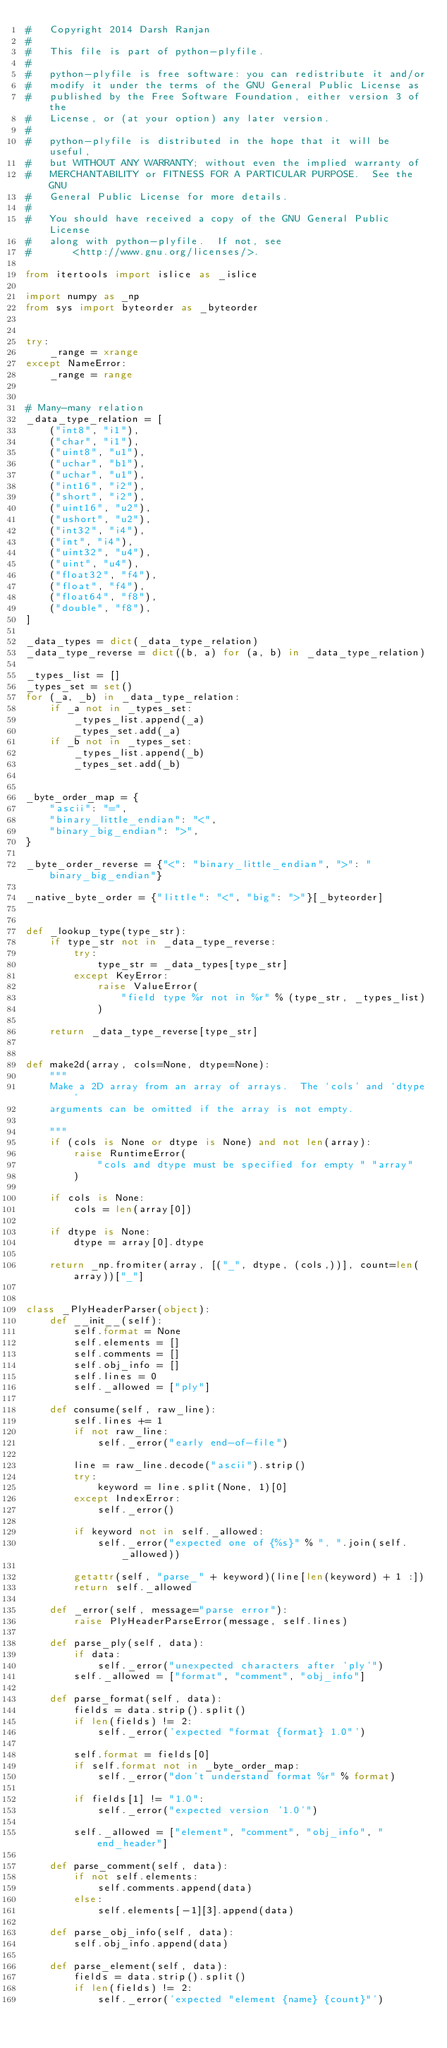<code> <loc_0><loc_0><loc_500><loc_500><_Python_>#   Copyright 2014 Darsh Ranjan
#
#   This file is part of python-plyfile.
#
#   python-plyfile is free software: you can redistribute it and/or
#   modify it under the terms of the GNU General Public License as
#   published by the Free Software Foundation, either version 3 of the
#   License, or (at your option) any later version.
#
#   python-plyfile is distributed in the hope that it will be useful,
#   but WITHOUT ANY WARRANTY; without even the implied warranty of
#   MERCHANTABILITY or FITNESS FOR A PARTICULAR PURPOSE.  See the GNU
#   General Public License for more details.
#
#   You should have received a copy of the GNU General Public License
#   along with python-plyfile.  If not, see
#       <http://www.gnu.org/licenses/>.

from itertools import islice as _islice

import numpy as _np
from sys import byteorder as _byteorder


try:
    _range = xrange
except NameError:
    _range = range


# Many-many relation
_data_type_relation = [
    ("int8", "i1"),
    ("char", "i1"),
    ("uint8", "u1"),
    ("uchar", "b1"),
    ("uchar", "u1"),
    ("int16", "i2"),
    ("short", "i2"),
    ("uint16", "u2"),
    ("ushort", "u2"),
    ("int32", "i4"),
    ("int", "i4"),
    ("uint32", "u4"),
    ("uint", "u4"),
    ("float32", "f4"),
    ("float", "f4"),
    ("float64", "f8"),
    ("double", "f8"),
]

_data_types = dict(_data_type_relation)
_data_type_reverse = dict((b, a) for (a, b) in _data_type_relation)

_types_list = []
_types_set = set()
for (_a, _b) in _data_type_relation:
    if _a not in _types_set:
        _types_list.append(_a)
        _types_set.add(_a)
    if _b not in _types_set:
        _types_list.append(_b)
        _types_set.add(_b)


_byte_order_map = {
    "ascii": "=",
    "binary_little_endian": "<",
    "binary_big_endian": ">",
}

_byte_order_reverse = {"<": "binary_little_endian", ">": "binary_big_endian"}

_native_byte_order = {"little": "<", "big": ">"}[_byteorder]


def _lookup_type(type_str):
    if type_str not in _data_type_reverse:
        try:
            type_str = _data_types[type_str]
        except KeyError:
            raise ValueError(
                "field type %r not in %r" % (type_str, _types_list)
            )

    return _data_type_reverse[type_str]


def make2d(array, cols=None, dtype=None):
    """
    Make a 2D array from an array of arrays.  The `cols' and `dtype'
    arguments can be omitted if the array is not empty.

    """
    if (cols is None or dtype is None) and not len(array):
        raise RuntimeError(
            "cols and dtype must be specified for empty " "array"
        )

    if cols is None:
        cols = len(array[0])

    if dtype is None:
        dtype = array[0].dtype

    return _np.fromiter(array, [("_", dtype, (cols,))], count=len(array))["_"]


class _PlyHeaderParser(object):
    def __init__(self):
        self.format = None
        self.elements = []
        self.comments = []
        self.obj_info = []
        self.lines = 0
        self._allowed = ["ply"]

    def consume(self, raw_line):
        self.lines += 1
        if not raw_line:
            self._error("early end-of-file")

        line = raw_line.decode("ascii").strip()
        try:
            keyword = line.split(None, 1)[0]
        except IndexError:
            self._error()

        if keyword not in self._allowed:
            self._error("expected one of {%s}" % ", ".join(self._allowed))

        getattr(self, "parse_" + keyword)(line[len(keyword) + 1 :])
        return self._allowed

    def _error(self, message="parse error"):
        raise PlyHeaderParseError(message, self.lines)

    def parse_ply(self, data):
        if data:
            self._error("unexpected characters after 'ply'")
        self._allowed = ["format", "comment", "obj_info"]

    def parse_format(self, data):
        fields = data.strip().split()
        if len(fields) != 2:
            self._error('expected "format {format} 1.0"')

        self.format = fields[0]
        if self.format not in _byte_order_map:
            self._error("don't understand format %r" % format)

        if fields[1] != "1.0":
            self._error("expected version '1.0'")

        self._allowed = ["element", "comment", "obj_info", "end_header"]

    def parse_comment(self, data):
        if not self.elements:
            self.comments.append(data)
        else:
            self.elements[-1][3].append(data)

    def parse_obj_info(self, data):
        self.obj_info.append(data)

    def parse_element(self, data):
        fields = data.strip().split()
        if len(fields) != 2:
            self._error('expected "element {name} {count}"')
</code> 